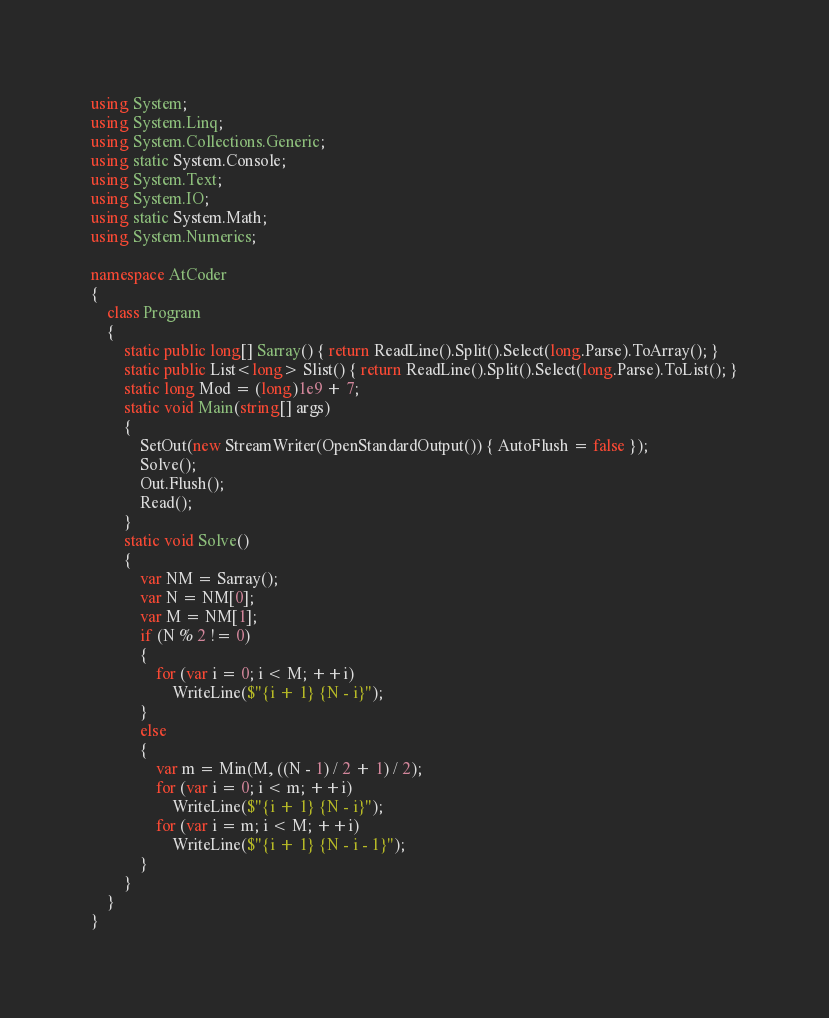Convert code to text. <code><loc_0><loc_0><loc_500><loc_500><_C#_>using System;
using System.Linq;
using System.Collections.Generic;
using static System.Console;
using System.Text;
using System.IO;
using static System.Math;
using System.Numerics;

namespace AtCoder
{
    class Program
    {
        static public long[] Sarray() { return ReadLine().Split().Select(long.Parse).ToArray(); }
        static public List<long> Slist() { return ReadLine().Split().Select(long.Parse).ToList(); }
        static long Mod = (long)1e9 + 7;
        static void Main(string[] args)
        {
            SetOut(new StreamWriter(OpenStandardOutput()) { AutoFlush = false });
            Solve();
            Out.Flush();
            Read();
        }
        static void Solve()
        {
            var NM = Sarray();
            var N = NM[0];
            var M = NM[1];
            if (N % 2 != 0)
            {
                for (var i = 0; i < M; ++i)
                    WriteLine($"{i + 1} {N - i}");
            }
            else
            {
                var m = Min(M, ((N - 1) / 2 + 1) / 2);
                for (var i = 0; i < m; ++i)
                    WriteLine($"{i + 1} {N - i}");
                for (var i = m; i < M; ++i)
                    WriteLine($"{i + 1} {N - i - 1}");
            }
        }
    }
}</code> 